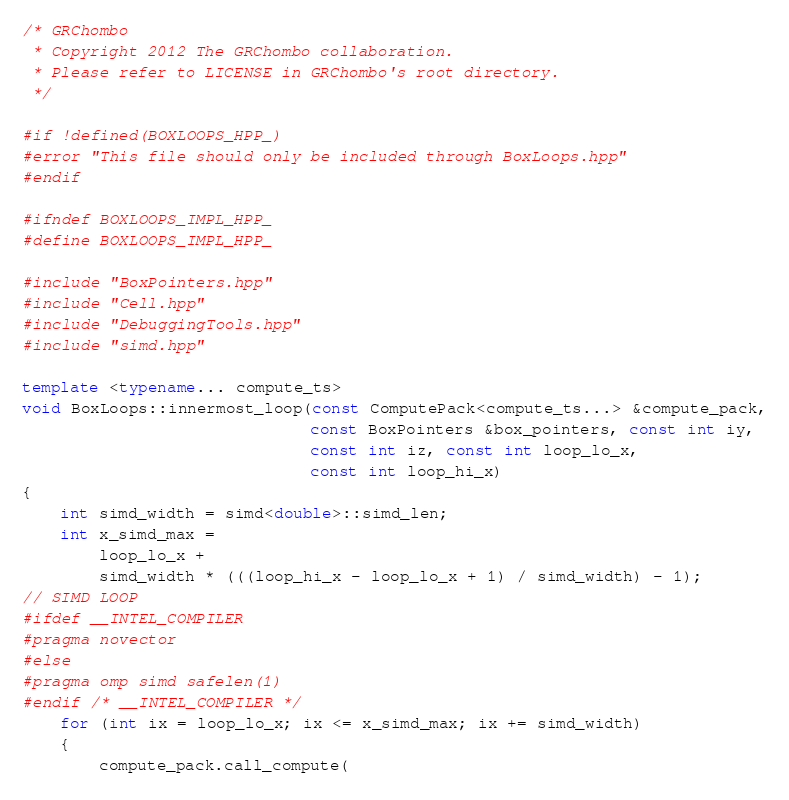<code> <loc_0><loc_0><loc_500><loc_500><_C++_>/* GRChombo
 * Copyright 2012 The GRChombo collaboration.
 * Please refer to LICENSE in GRChombo's root directory.
 */

#if !defined(BOXLOOPS_HPP_)
#error "This file should only be included through BoxLoops.hpp"
#endif

#ifndef BOXLOOPS_IMPL_HPP_
#define BOXLOOPS_IMPL_HPP_

#include "BoxPointers.hpp"
#include "Cell.hpp"
#include "DebuggingTools.hpp"
#include "simd.hpp"

template <typename... compute_ts>
void BoxLoops::innermost_loop(const ComputePack<compute_ts...> &compute_pack,
                              const BoxPointers &box_pointers, const int iy,
                              const int iz, const int loop_lo_x,
                              const int loop_hi_x)
{
    int simd_width = simd<double>::simd_len;
    int x_simd_max =
        loop_lo_x +
        simd_width * (((loop_hi_x - loop_lo_x + 1) / simd_width) - 1);
// SIMD LOOP
#ifdef __INTEL_COMPILER
#pragma novector
#else
#pragma omp simd safelen(1)
#endif /* __INTEL_COMPILER */
    for (int ix = loop_lo_x; ix <= x_simd_max; ix += simd_width)
    {
        compute_pack.call_compute(</code> 